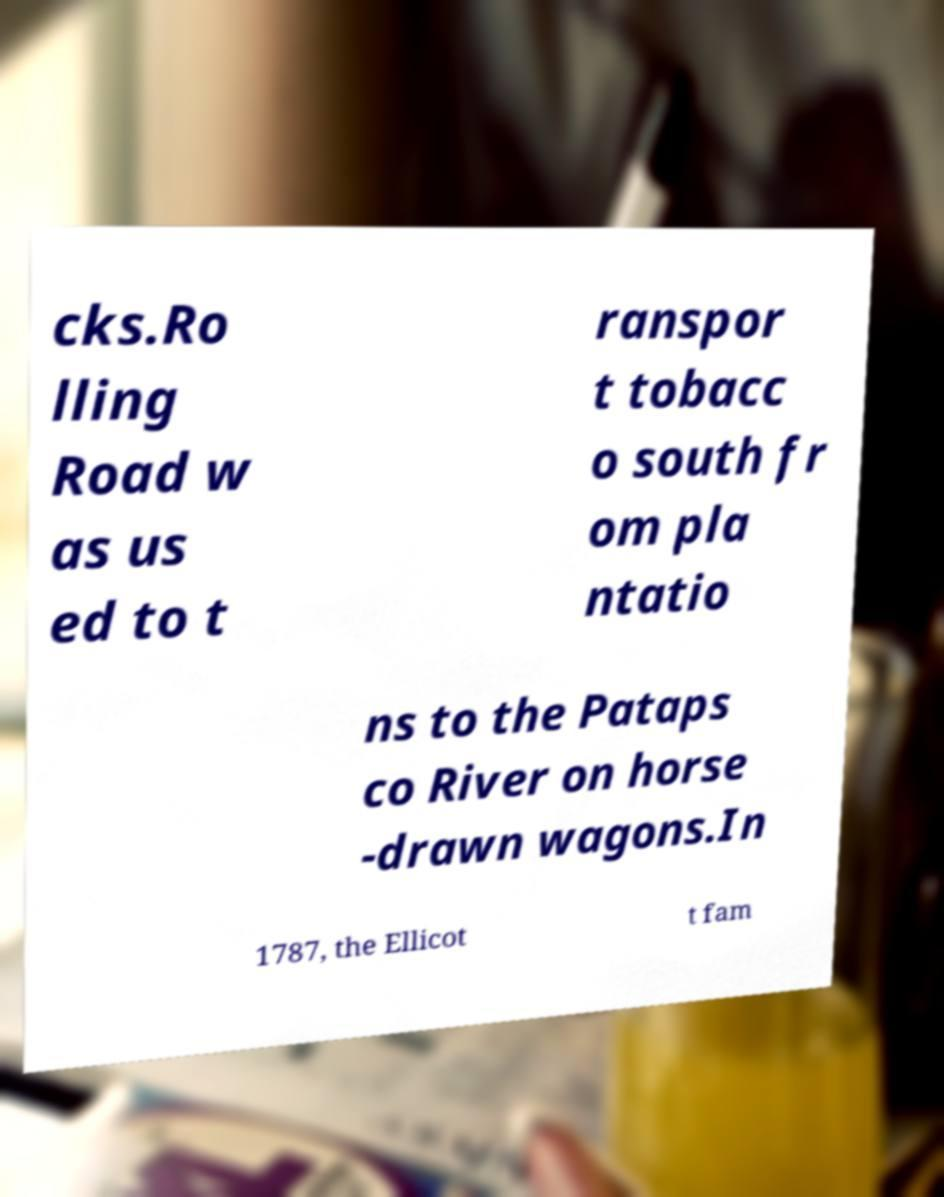Please read and relay the text visible in this image. What does it say? cks.Ro lling Road w as us ed to t ranspor t tobacc o south fr om pla ntatio ns to the Pataps co River on horse -drawn wagons.In 1787, the Ellicot t fam 